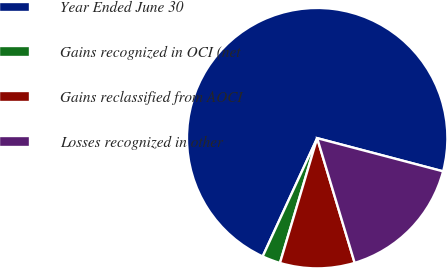Convert chart to OTSL. <chart><loc_0><loc_0><loc_500><loc_500><pie_chart><fcel>Year Ended June 30<fcel>Gains recognized in OCI (net<fcel>Gains reclassified from AOCI<fcel>Losses recognized in other<nl><fcel>72.23%<fcel>2.26%<fcel>9.26%<fcel>16.25%<nl></chart> 